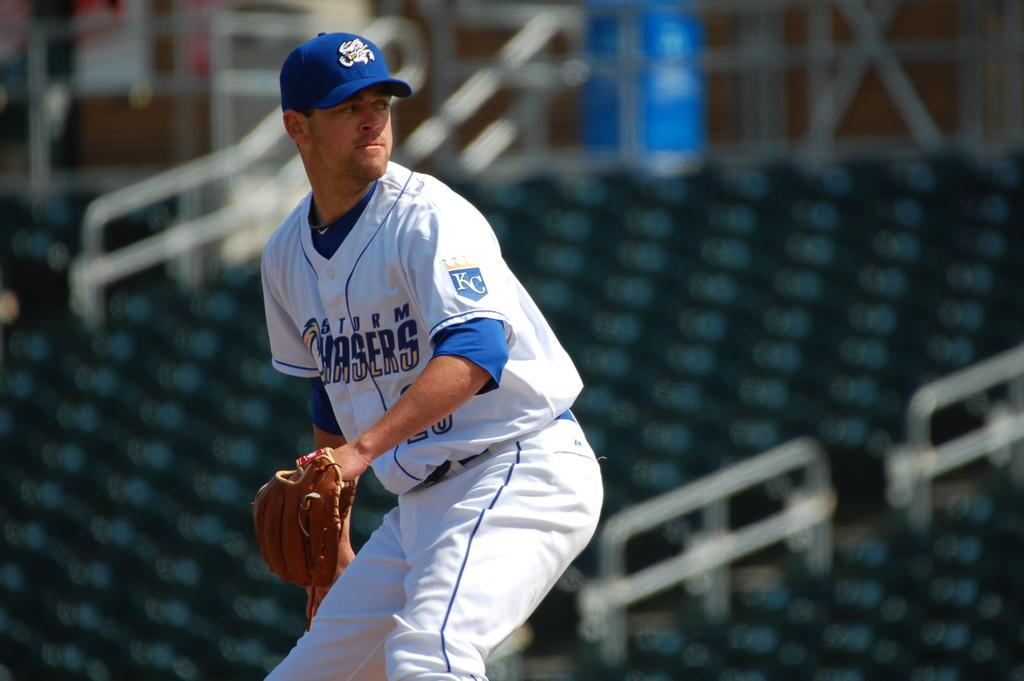<image>
Give a short and clear explanation of the subsequent image. A man wearing a Storm Chasers baseball jersey is in position for play. 